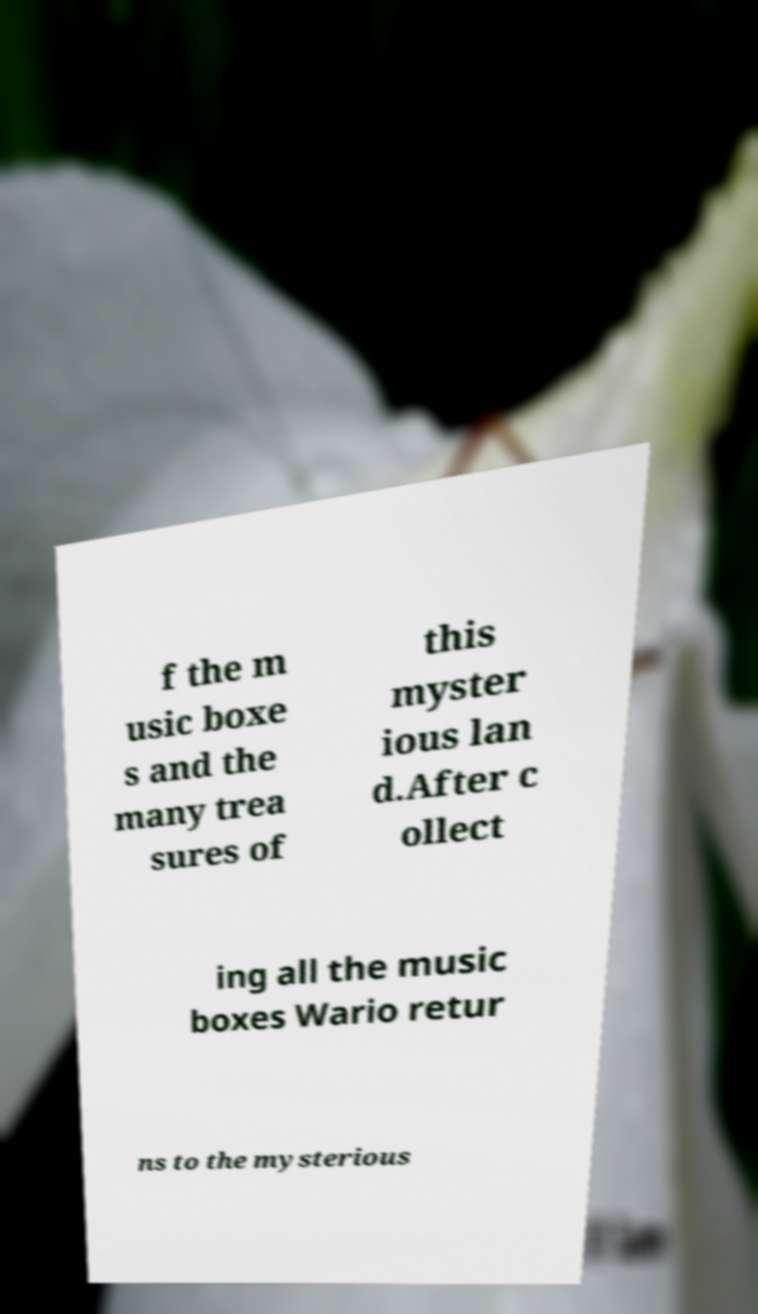What messages or text are displayed in this image? I need them in a readable, typed format. f the m usic boxe s and the many trea sures of this myster ious lan d.After c ollect ing all the music boxes Wario retur ns to the mysterious 